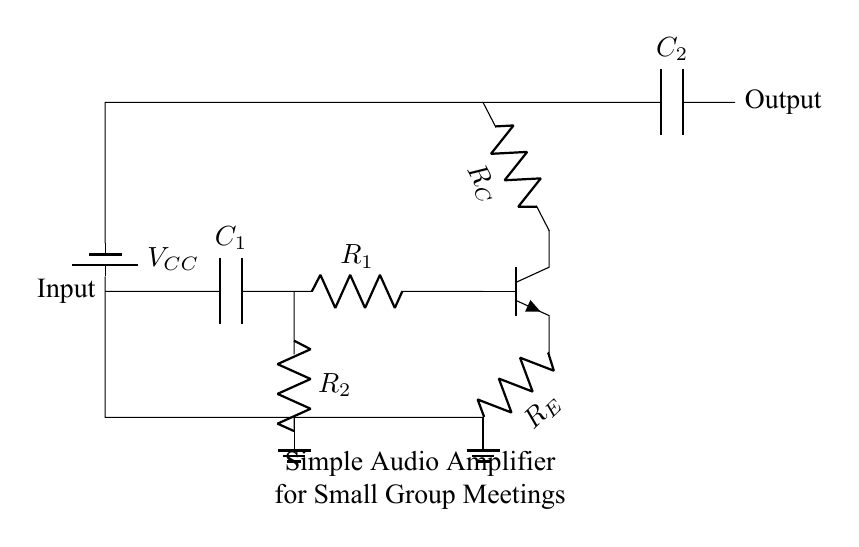What is the role of the capacitor C1? The capacitor C1 serves as a coupling capacitor, allowing AC signals to pass while blocking DC. This is important for maintaining signal integrity in audio applications.
Answer: Coupling What type of transistor is used in this circuit? The circuit shows an npn transistor, indicated by the symbol in the diagram. Npn transistors are commonly used in amplifiers due to their ability to amplify current.
Answer: Npn What is V_CC in the circuit? V_CC is the supply voltage for the circuit, providing power to the amplifier components. In this case, it typically represents the positive voltage source connected to the collector of the transistor.
Answer: Supply voltage Which resistors are forming a voltage divider in this circuit? The resistors R1 and R2 are in parallel configuration and work together to set the bias point for the transistor, but they do not create a traditional voltage divider in this layout. However, R1 serves to limit current.
Answer: R1, R2 What is the expected output of this audio amplifier? The expected output is an amplified version of the input audio signal, intended for small group settings. The output will have increased volume compared to the input signal.
Answer: Amplified audio How many capacitors are present in the circuit? There are two capacitors in the circuit, C1 and C2. Capacitors in amplifier circuits generally serve different purposes, including coupling and filtering.
Answer: Two 